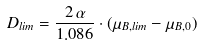Convert formula to latex. <formula><loc_0><loc_0><loc_500><loc_500>D _ { l i m } = \frac { 2 \, \alpha } { 1 . 0 8 6 } \cdot ( \mu _ { B , l i m } - \mu _ { B , 0 } )</formula> 